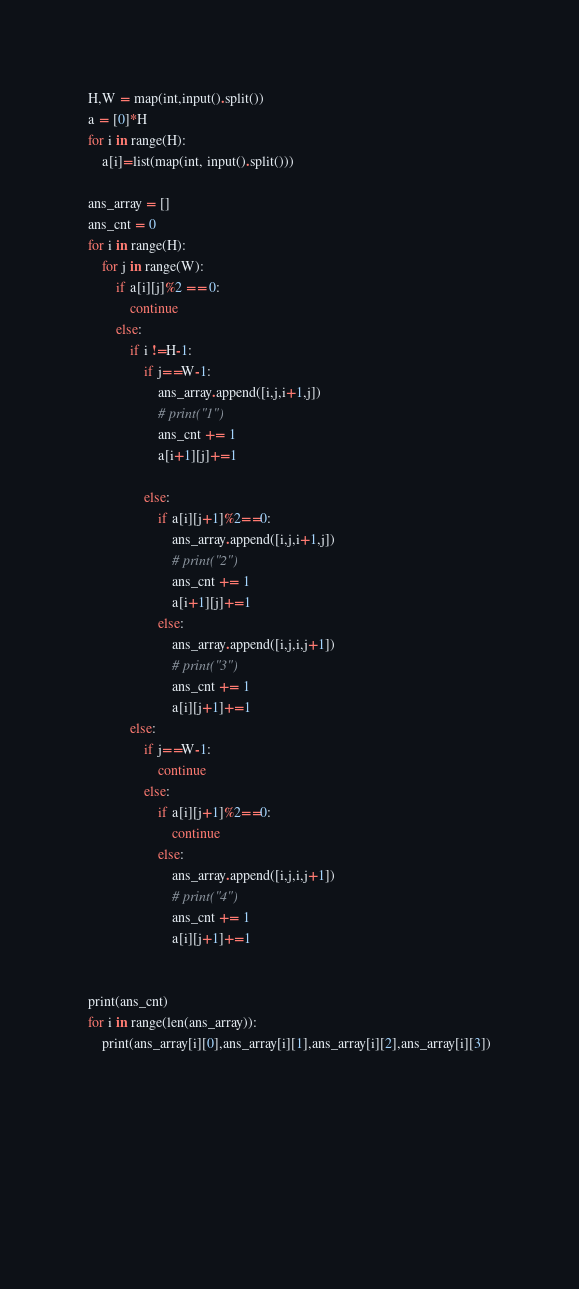Convert code to text. <code><loc_0><loc_0><loc_500><loc_500><_Python_>
H,W = map(int,input().split())
a = [0]*H
for i in range(H):
    a[i]=list(map(int, input().split()))

ans_array = []
ans_cnt = 0
for i in range(H):
    for j in range(W):
        if a[i][j]%2 == 0:
            continue
        else:
            if i !=H-1: 
                if j==W-1:
                    ans_array.append([i,j,i+1,j])
                    # print("1")
                    ans_cnt += 1
                    a[i+1][j]+=1

                else:
                    if a[i][j+1]%2==0:
                        ans_array.append([i,j,i+1,j])
                        # print("2")
                        ans_cnt += 1
                        a[i+1][j]+=1
                    else: 
                        ans_array.append([i,j,i,j+1])
                        # print("3")
                        ans_cnt += 1
                        a[i][j+1]+=1
            else:
                if j==W-1:
                    continue
                else:
                    if a[i][j+1]%2==0:
                        continue
                    else:
                        ans_array.append([i,j,i,j+1])
                        # print("4")
                        ans_cnt += 1
                        a[i][j+1]+=1


print(ans_cnt)
for i in range(len(ans_array)):
    print(ans_array[i][0],ans_array[i][1],ans_array[i][2],ans_array[i][3])



                    
                    

                
</code> 